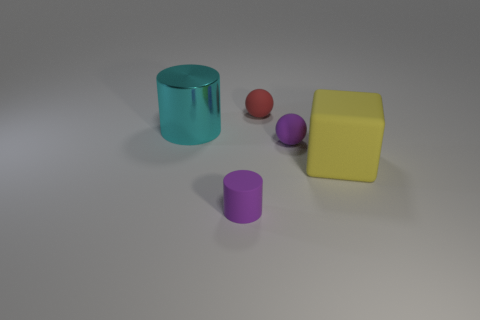How many rubber things are either purple cylinders or big purple cylinders?
Your answer should be very brief. 1. Is the big metallic object the same color as the large rubber block?
Provide a succinct answer. No. Is the number of cyan cylinders in front of the cyan metallic cylinder greater than the number of large yellow cubes?
Give a very brief answer. No. What number of other things are made of the same material as the large yellow cube?
Provide a succinct answer. 3. How many large things are either blue cylinders or cyan shiny objects?
Make the answer very short. 1. Does the tiny purple ball have the same material as the purple cylinder?
Provide a succinct answer. Yes. There is a tiny purple rubber object right of the purple cylinder; what number of tiny purple matte balls are on the left side of it?
Your answer should be compact. 0. Are there an equal number of cyan cylinders and big red things?
Your response must be concise. No. Are there any brown objects that have the same shape as the red object?
Give a very brief answer. No. Is the shape of the big object that is behind the big yellow rubber thing the same as the large yellow object that is to the right of the large cyan thing?
Provide a succinct answer. No. 